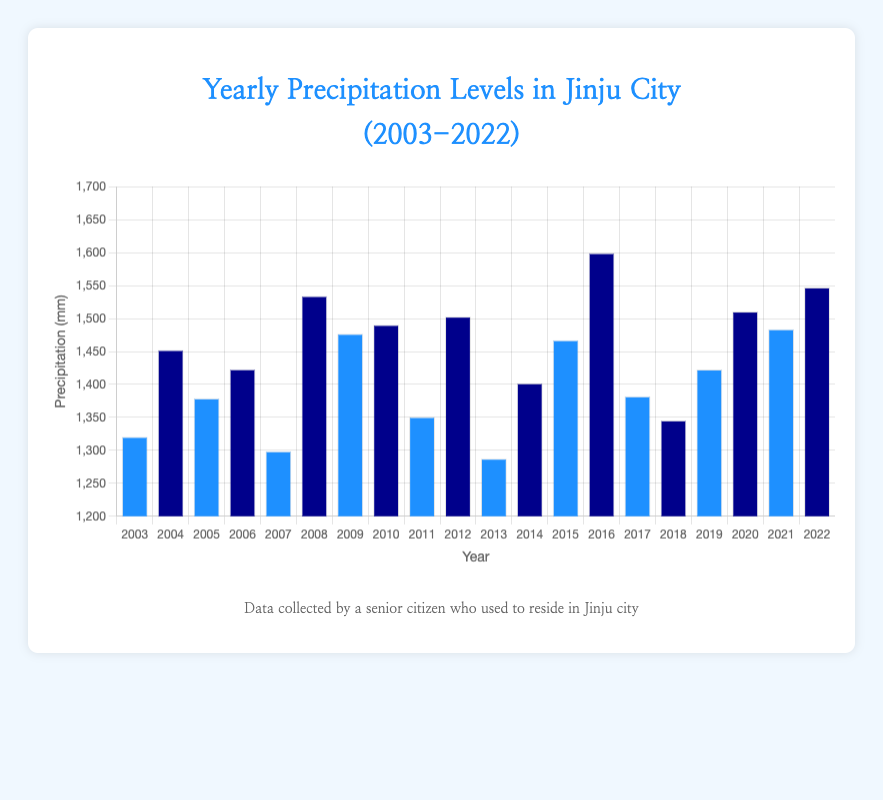What's the average yearly precipitation level from 2003 to 2022? To find the average precipitation level, sum all the precipitation levels from 2003 to 2022 and divide by the number of years. Sum: 1320.5 + 1452.3 + 1378.9 + 1423.1 + 1298.7 + 1534.2 + 1476.8 + 1490.4 + 1350.6 + 1502.9 + 1287.4 + 1401.8 + 1467.2 + 1599.3 + 1382.0 + 1345.5 + 1422.7 + 1510.6 + 1483.8 + 1547.2 = 29074.9, Average: 29074.9 / 20 = 1453.745
Answer: 1453.745 mm In which year was the precipitation level the highest? Identify the tallest bar in the chart that represents the highest precipitation level. The highest value in the data is 1599.3 mm in 2016.
Answer: 2016 Which year had the lowest precipitation level? Identify the shortest bar in the chart that represents the lowest precipitation level. The lowest value in the data is 1287.4 mm in 2013.
Answer: 2013 What is the difference in precipitation levels between 2008 and 2003? Calculate the difference between the precipitation levels of 2008 and 2003. Difference: 1534.2 mm (2008) - 1320.5 mm (2003) = 213.7 mm
Answer: 213.7 mm By how much did the precipitation level change from 2011 to 2012? Calculate the difference between the precipitation levels of 2012 and 2011. Difference: 1502.9 mm (2012) - 1350.6 mm (2011) = 152.3 mm
Answer: 152.3 mm What is the combined precipitation level for the years 2018, 2019, and 2020? Add the precipitation levels of the years 2018, 2019, and 2020. Sum: 1345.5 mm (2018) + 1422.7 mm (2019) + 1510.6 mm (2020) = 4288.8 mm
Answer: 4288.8 mm How many years had a precipitation level greater than 1500 mm? Count the number of bars that exceed the 1500 mm mark in the chart. The years are 2008, 2012, 2016, 2020, and 2022. A total of 5 years exceed 1500 mm.
Answer: 5 years What is the median precipitation level from 2003 to 2022? First, order all precipitation levels. With 20 values, the median is the average of the 10th and 11th values in the ordered list. Ordered: 1287.4, 1298.7, 1320.5, 1345.5, 1350.6, 1378.9, 1382.0, 1401.8, 1422.7, 1423.1, 1452.3, 1467.2, 1476.8, 1483.8, 1490.4, 1502.9, 1510.6, 1534.2, 1547.2, 1599.3. Median: (1423.1 + 1452.3) / 2 = 1437.7
Answer: 1437.7 mm Which color bars represent even years? Observing the color pattern, the blue bars represent even years.
Answer: Blue Which year had a higher precipitation level: 2010 or 2021? Compare the heights or values of the bars for 2010 and 2021. For 2010, it is 1490.4 mm; for 2021, it is 1483.8 mm. 2010 has a higher precipitation level.
Answer: 2010 